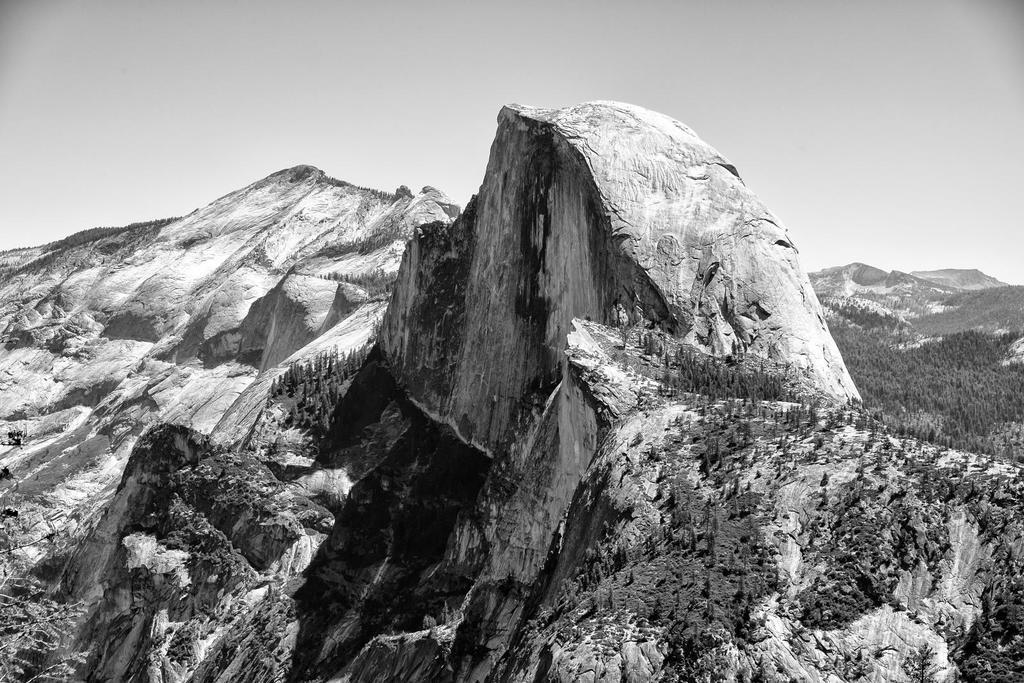What is the color scheme of the image? The image is black and white. What type of landscape can be seen in the image? There are hills and trees in the image. What part of the natural environment is visible in the image? The sky is visible in the image. Can you see any corn growing in the image? There is no corn visible in the image. Are there any people kissing in the image? There are no people or any indication of a kiss in the image. 